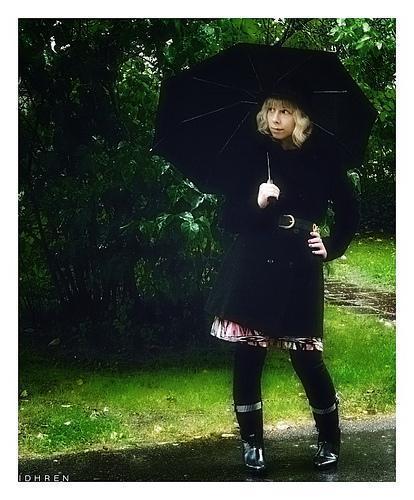How many arched windows are there to the left of the clock tower?
Give a very brief answer. 0. 